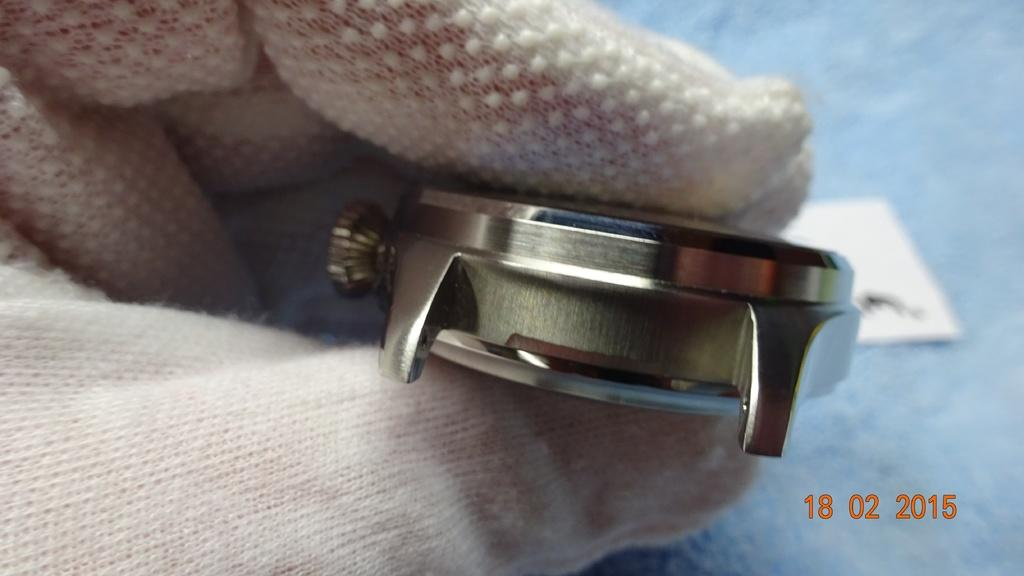What is the hand holding in the image? The hand is holding a watch in the image. What is covering the hand in the image? The hand is wearing gloves in the image. What color is the background of the image? The background of the image is blue. What material is the image printed on? The image is printed on paper. What type of collar is visible on the friends in the image? There are no friends or collars present in the image; it only features a hand holding a watch. 